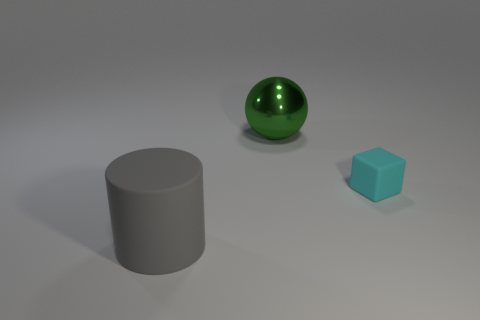What shapes are present in the image? There are three shapes: a green sphere, a gray cylinder, and a blue cube.  Can you tell which object seems the heaviest based on the image? While the actual weight cannot be discerned from the image alone, the gray cylinder appears to have the most mass and could be perceived as the heaviest. 